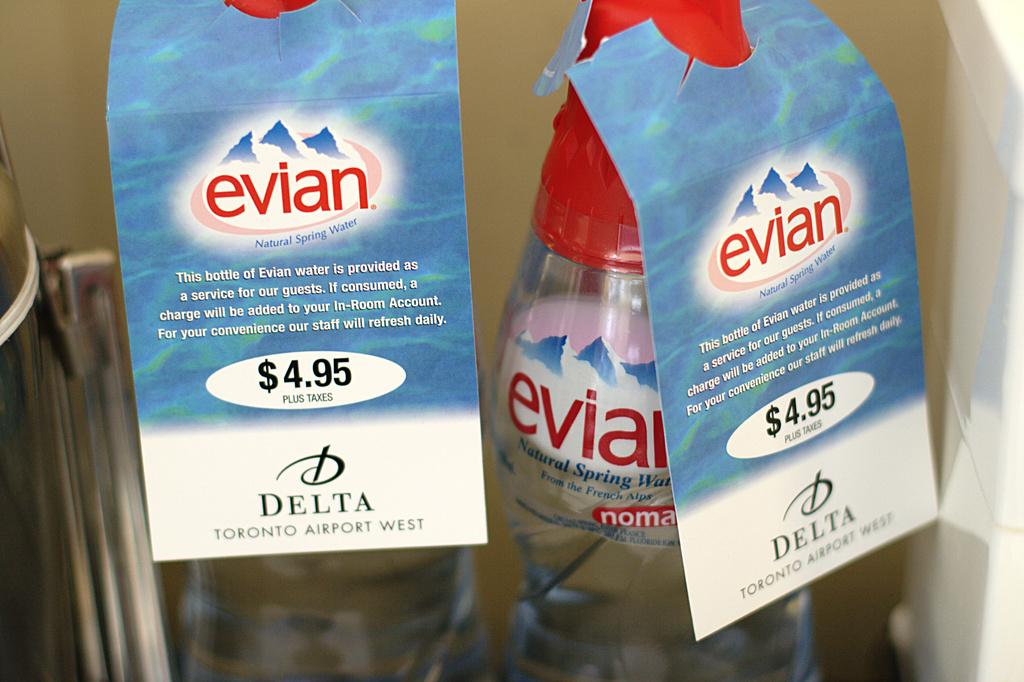<image>
Describe the image concisely. two bottles of evian water for sale at the delta toronto airport west 